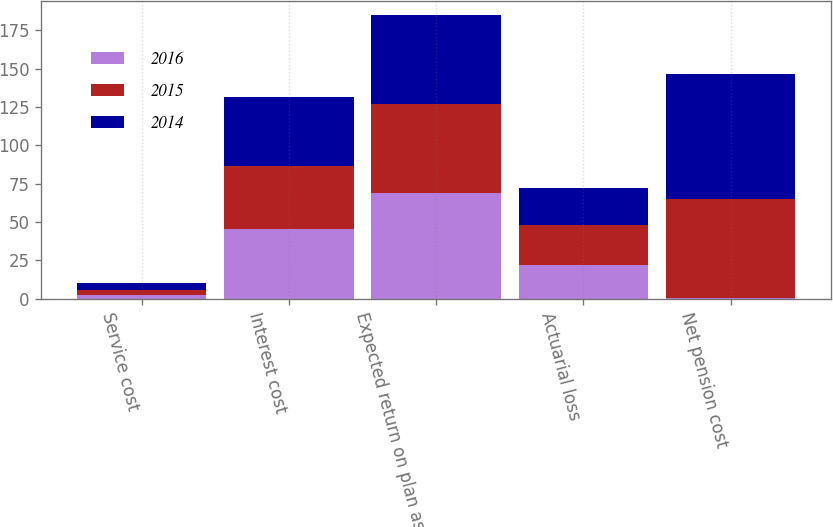Convert chart. <chart><loc_0><loc_0><loc_500><loc_500><stacked_bar_chart><ecel><fcel>Service cost<fcel>Interest cost<fcel>Expected return on plan assets<fcel>Actuarial loss<fcel>Net pension cost<nl><fcel>2016<fcel>2.7<fcel>45.1<fcel>69.1<fcel>21.8<fcel>0.4<nl><fcel>2015<fcel>3.2<fcel>41.3<fcel>58<fcel>26.2<fcel>64.7<nl><fcel>2014<fcel>4.1<fcel>45.1<fcel>57.5<fcel>24.2<fcel>81.3<nl></chart> 